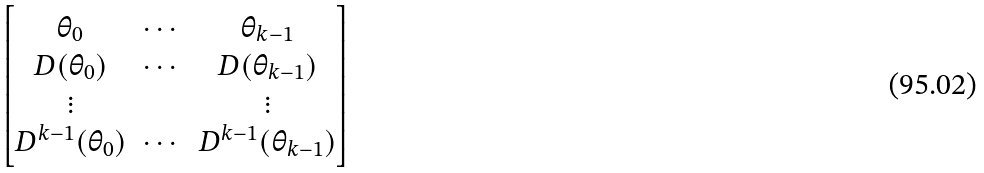Convert formula to latex. <formula><loc_0><loc_0><loc_500><loc_500>\begin{bmatrix} \theta _ { 0 } & \cdots & \theta _ { k - 1 } \\ D ( \theta _ { 0 } ) & \cdots & D ( \theta _ { k - 1 } ) \\ \vdots & & \vdots \\ D ^ { k - 1 } ( \theta _ { 0 } ) & \cdots & D ^ { k - 1 } ( \theta _ { k - 1 } ) \end{bmatrix}</formula> 